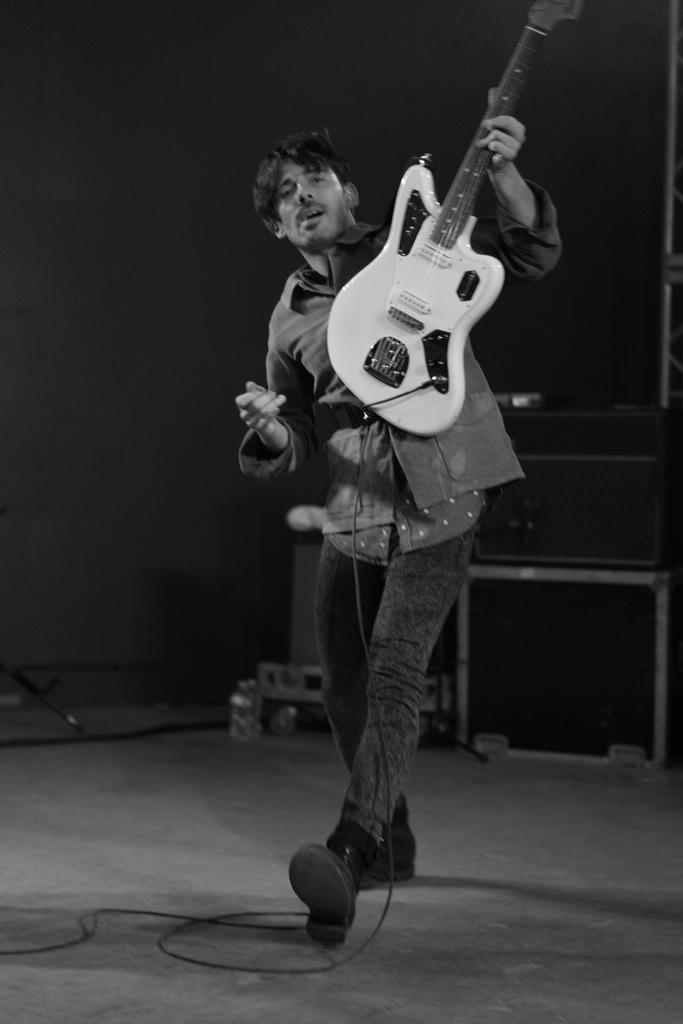What is the main subject of the image? The main subject of the image is a man. What is the man doing in the image? The man is standing in the image. What object is the man holding in the image? The man is holding a guitar in the image. What type of spark can be seen coming from the guitar in the image? There is no spark coming from the guitar in the image. What topic is the man talking about while holding the guitar? The image does not provide any information about what the man might be talking about. 